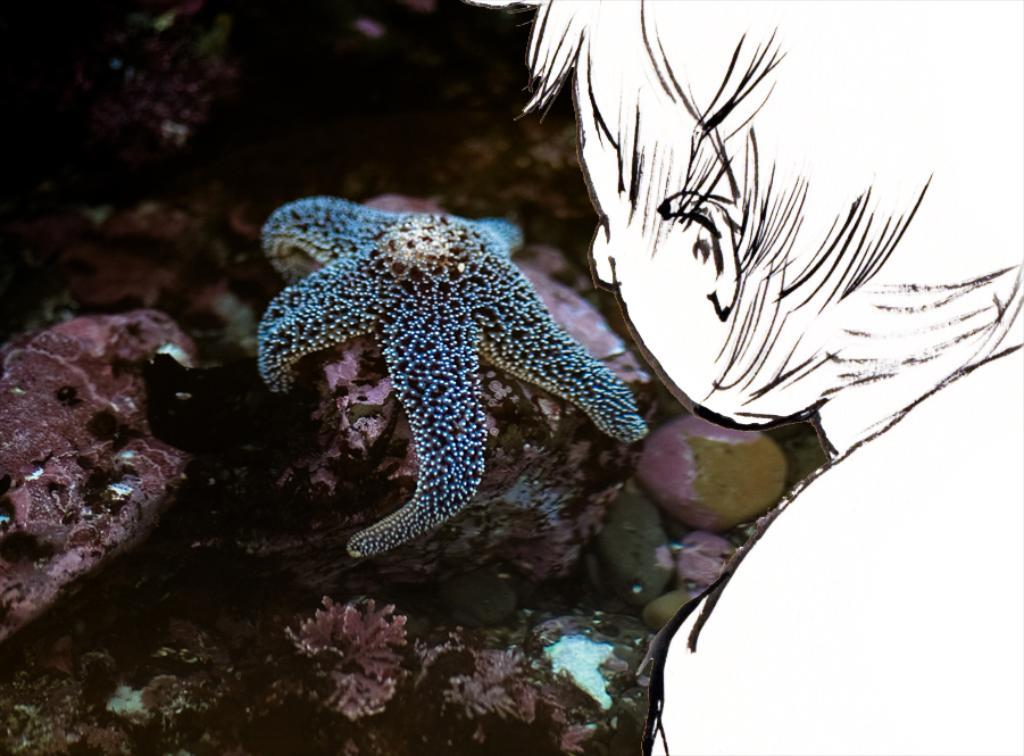What type of marine animal is in the image? There is a starfish in the image. What can be seen in the image besides the starfish? There are visible objects in the image. What is the primary element in which the starfish is situated? There is water in the image. What type of cake is being served on the stage in the image? There is no cake or stage present in the image; it features a starfish in water. 